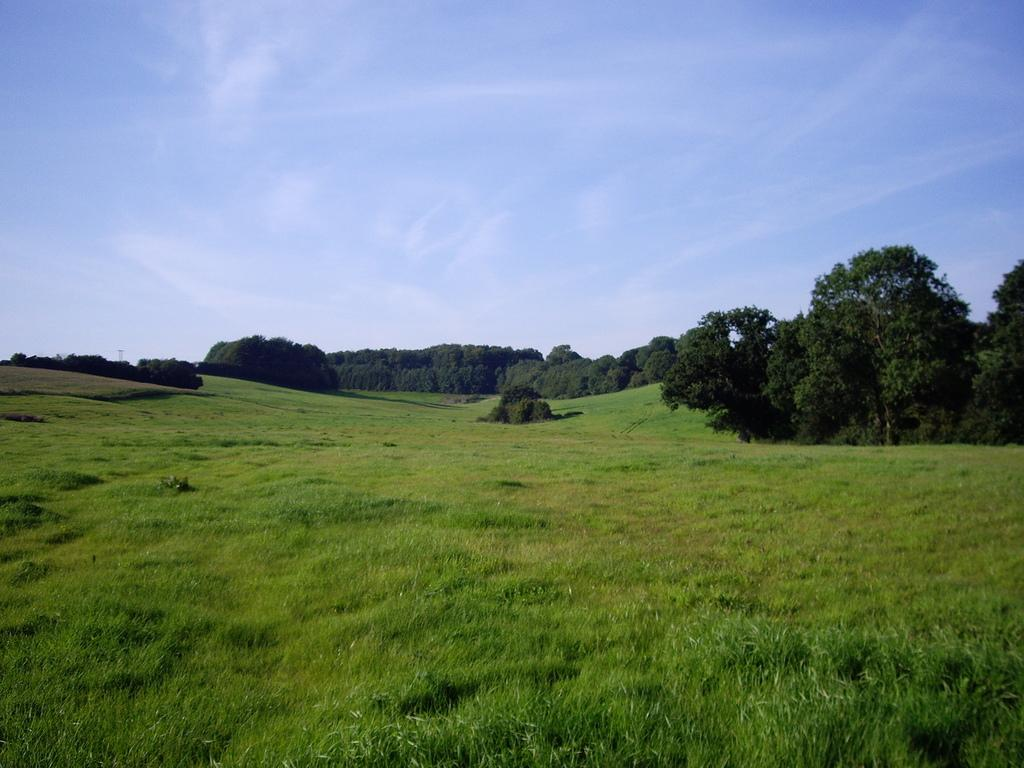What type of vegetation is present in the image? There is a group of trees in the image. What else can be seen in the image besides the trees? There is a grass field in the image. What is visible in the background of the image? The sky is visible in the background of the image. How would you describe the sky in the image? The sky appears to be cloudy. What type of account does the tree on the left have in the image? There are no accounts or financial information associated with the trees in the image. 